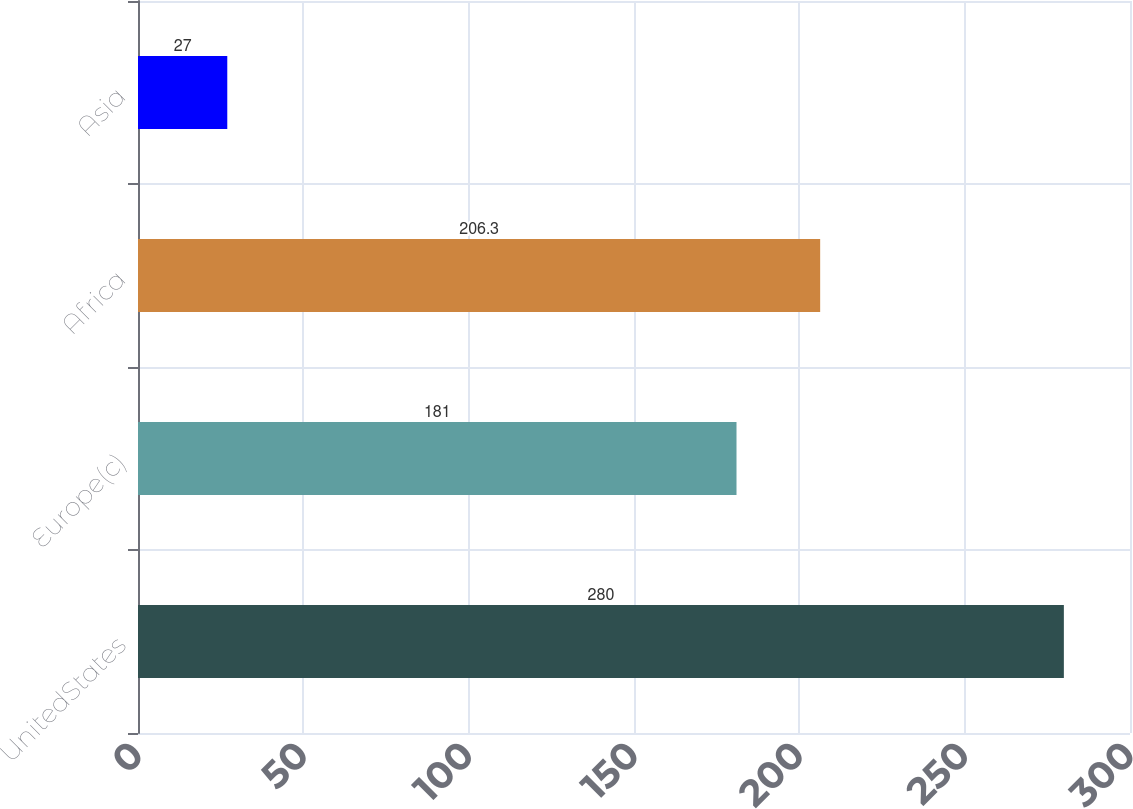<chart> <loc_0><loc_0><loc_500><loc_500><bar_chart><fcel>UnitedStates<fcel>Europe(c)<fcel>Africa<fcel>Asia<nl><fcel>280<fcel>181<fcel>206.3<fcel>27<nl></chart> 